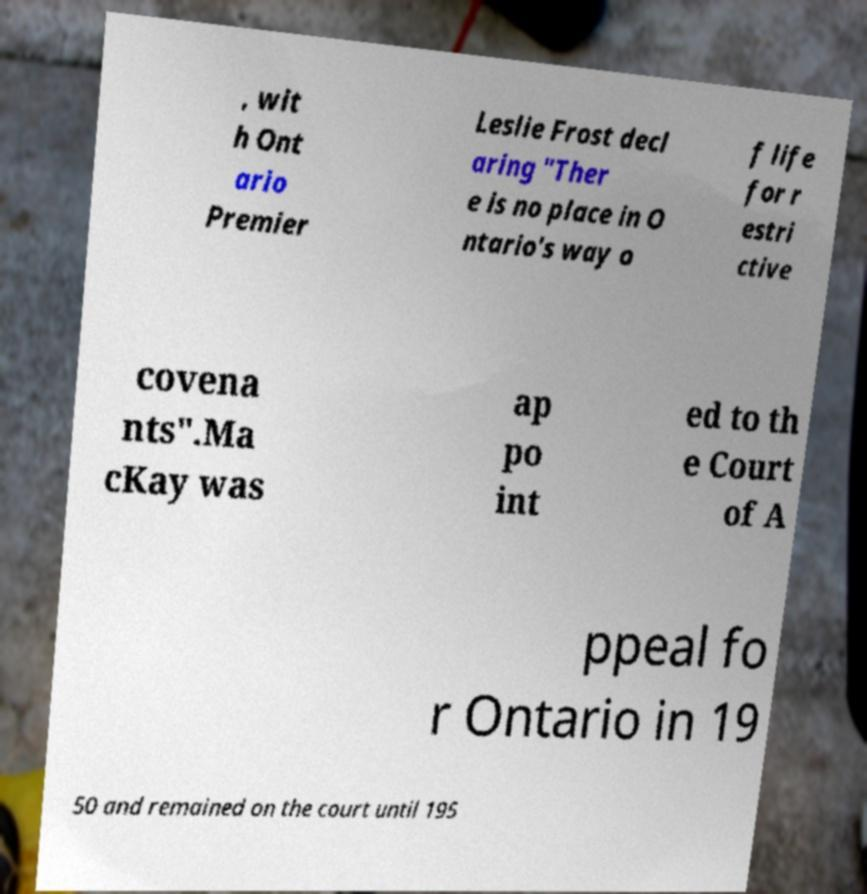Please identify and transcribe the text found in this image. , wit h Ont ario Premier Leslie Frost decl aring "Ther e is no place in O ntario's way o f life for r estri ctive covena nts".Ma cKay was ap po int ed to th e Court of A ppeal fo r Ontario in 19 50 and remained on the court until 195 